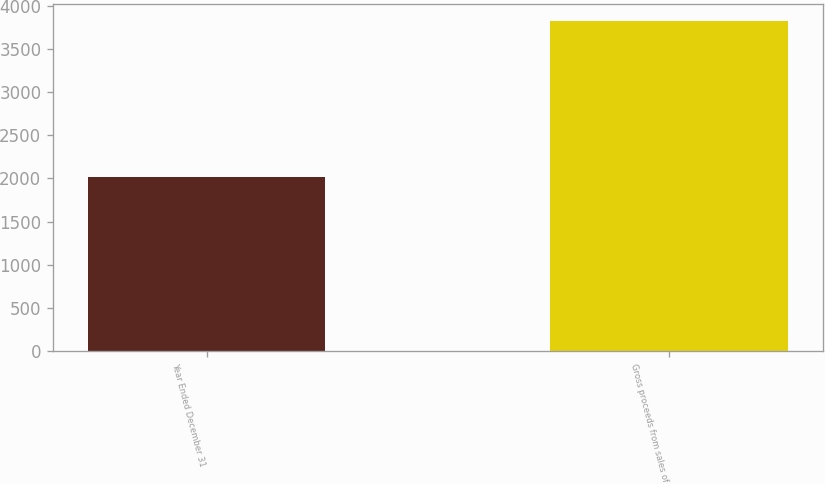Convert chart to OTSL. <chart><loc_0><loc_0><loc_500><loc_500><bar_chart><fcel>Year Ended December 31<fcel>Gross proceeds from sales of<nl><fcel>2014<fcel>3829<nl></chart> 